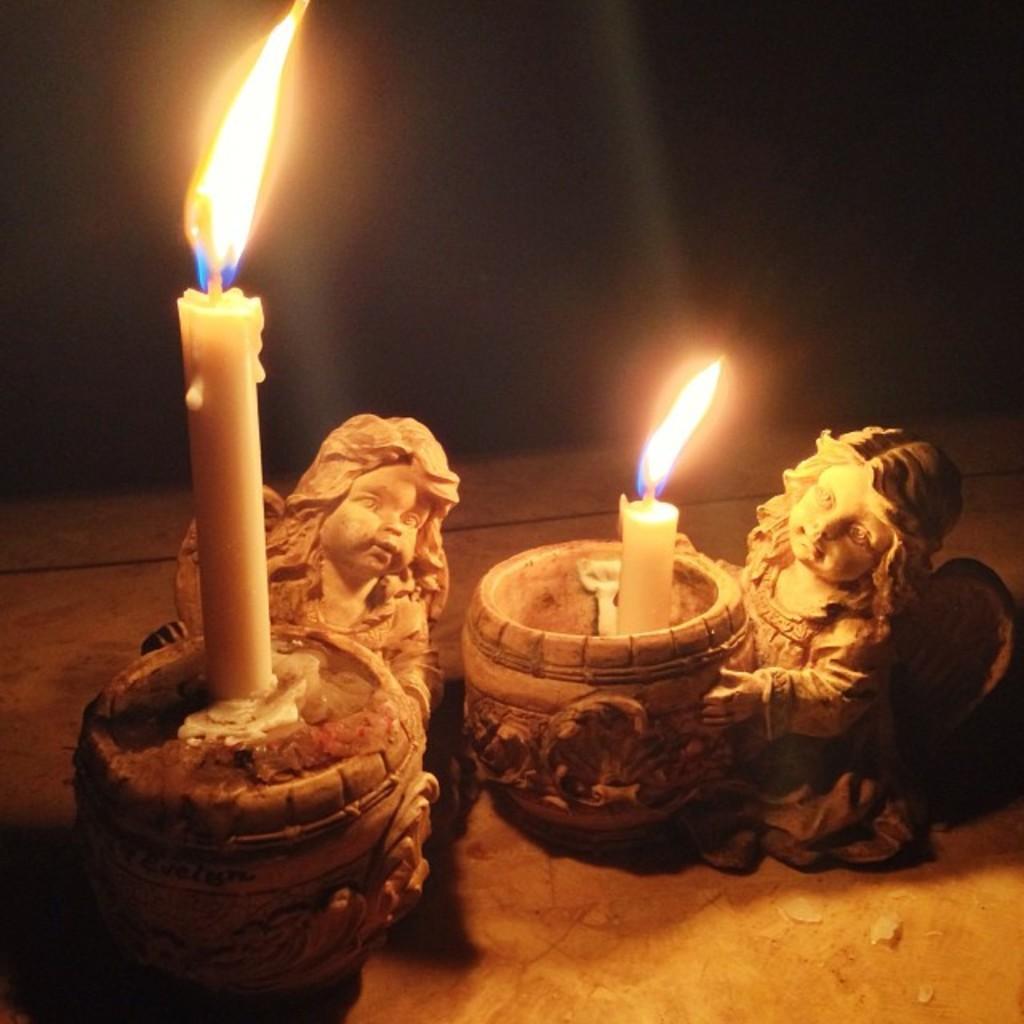Could you give a brief overview of what you see in this image? There are two statue candle holders are present on the surface as we can see at the bottom of this image. 